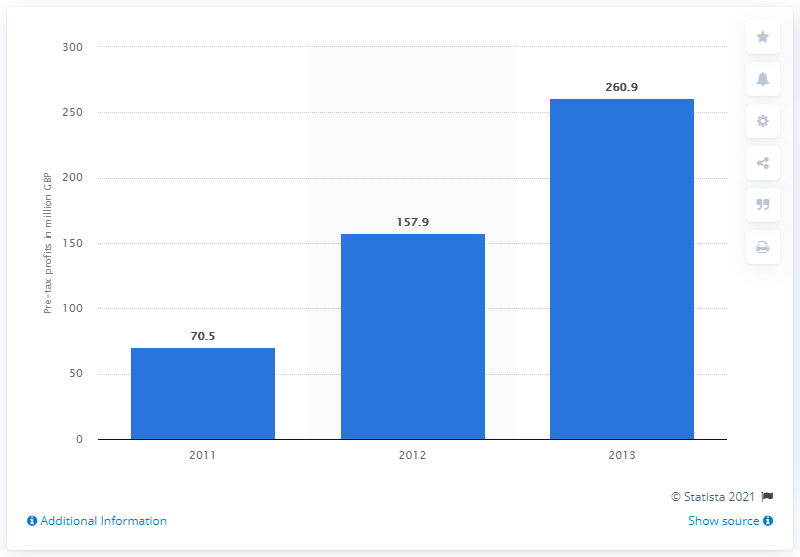Give some essential details in this illustration. Aldi's profit in 2013 was 260.9 million. In 2013, Aldi's pre-tax profits increased by almost 100 million pounds. 